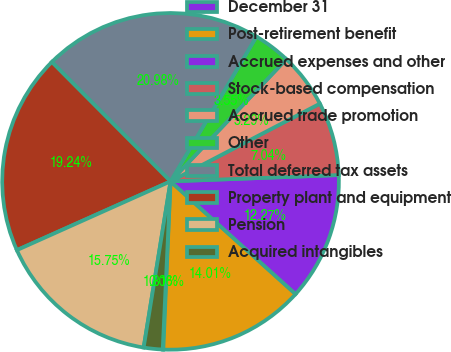<chart> <loc_0><loc_0><loc_500><loc_500><pie_chart><fcel>December 31<fcel>Post-retirement benefit<fcel>Accrued expenses and other<fcel>Stock-based compensation<fcel>Accrued trade promotion<fcel>Other<fcel>Total deferred tax assets<fcel>Property plant and equipment<fcel>Pension<fcel>Acquired intangibles<nl><fcel>0.06%<fcel>14.01%<fcel>12.27%<fcel>7.04%<fcel>5.29%<fcel>3.55%<fcel>20.98%<fcel>19.24%<fcel>15.75%<fcel>1.81%<nl></chart> 